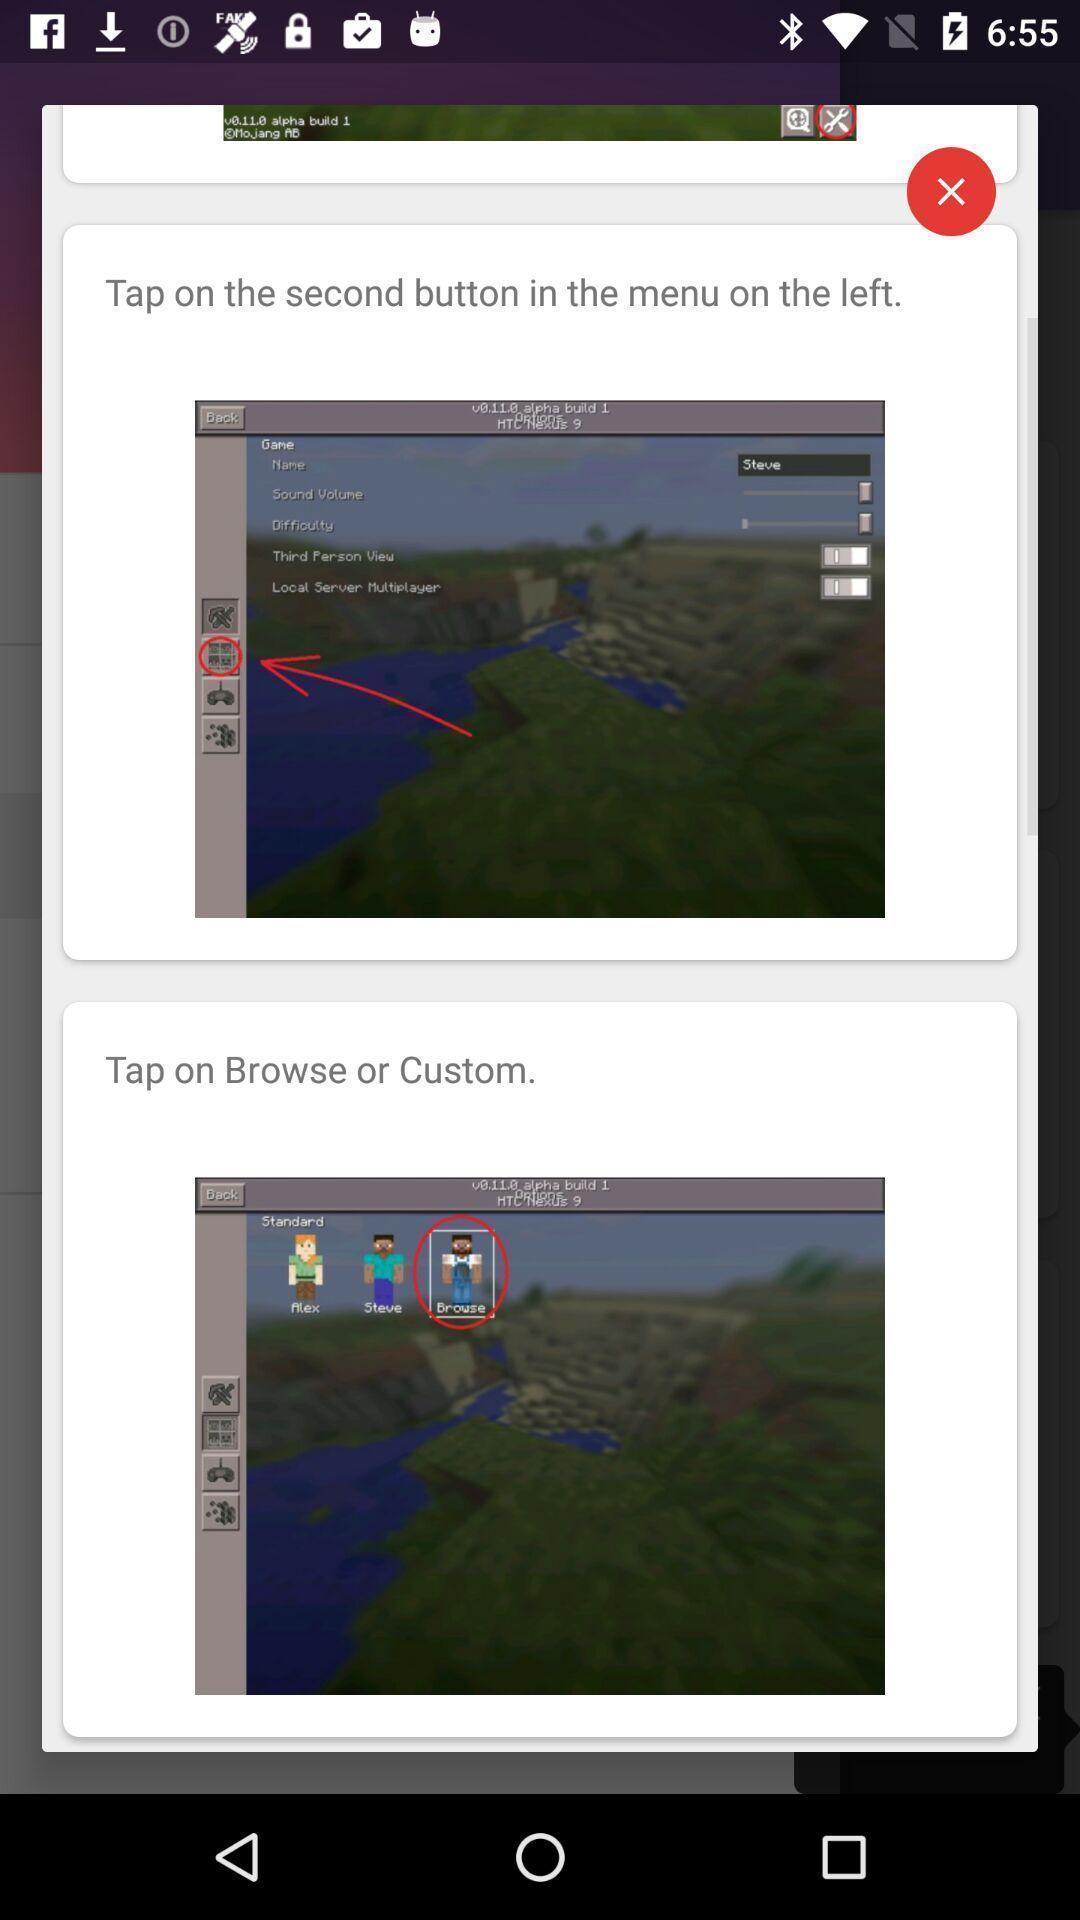Provide a description of this screenshot. Pictures page of a gaming app. 